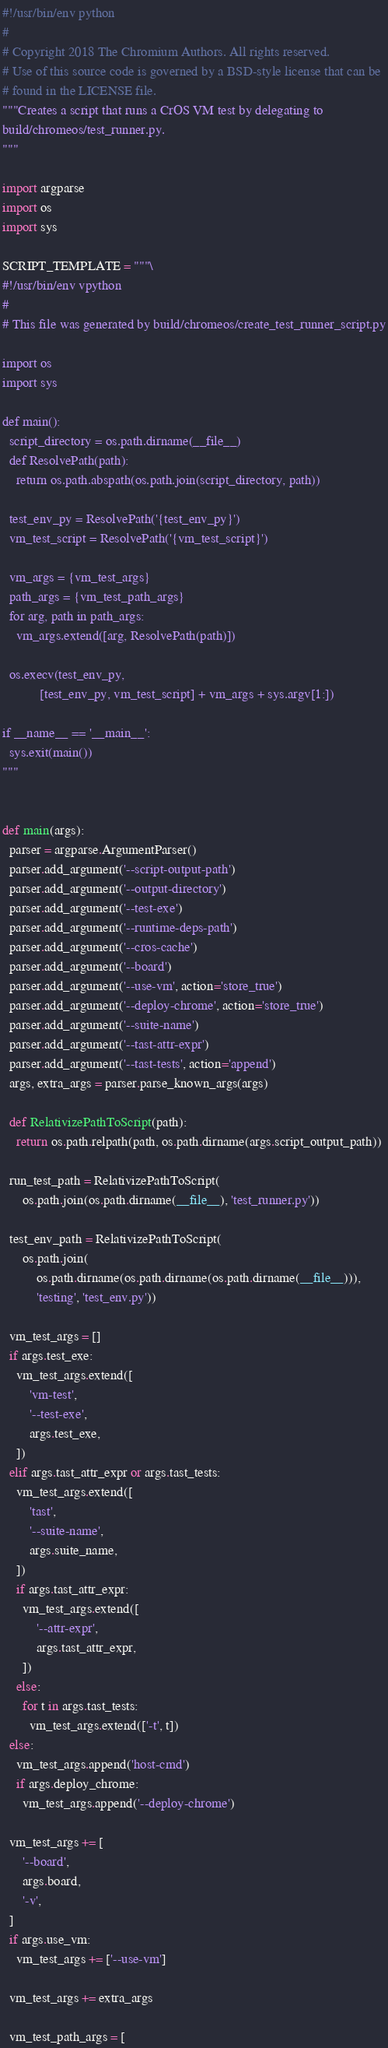<code> <loc_0><loc_0><loc_500><loc_500><_Python_>#!/usr/bin/env python
#
# Copyright 2018 The Chromium Authors. All rights reserved.
# Use of this source code is governed by a BSD-style license that can be
# found in the LICENSE file.
"""Creates a script that runs a CrOS VM test by delegating to
build/chromeos/test_runner.py.
"""

import argparse
import os
import sys

SCRIPT_TEMPLATE = """\
#!/usr/bin/env vpython
#
# This file was generated by build/chromeos/create_test_runner_script.py

import os
import sys

def main():
  script_directory = os.path.dirname(__file__)
  def ResolvePath(path):
    return os.path.abspath(os.path.join(script_directory, path))

  test_env_py = ResolvePath('{test_env_py}')
  vm_test_script = ResolvePath('{vm_test_script}')

  vm_args = {vm_test_args}
  path_args = {vm_test_path_args}
  for arg, path in path_args:
    vm_args.extend([arg, ResolvePath(path)])

  os.execv(test_env_py,
           [test_env_py, vm_test_script] + vm_args + sys.argv[1:])

if __name__ == '__main__':
  sys.exit(main())
"""


def main(args):
  parser = argparse.ArgumentParser()
  parser.add_argument('--script-output-path')
  parser.add_argument('--output-directory')
  parser.add_argument('--test-exe')
  parser.add_argument('--runtime-deps-path')
  parser.add_argument('--cros-cache')
  parser.add_argument('--board')
  parser.add_argument('--use-vm', action='store_true')
  parser.add_argument('--deploy-chrome', action='store_true')
  parser.add_argument('--suite-name')
  parser.add_argument('--tast-attr-expr')
  parser.add_argument('--tast-tests', action='append')
  args, extra_args = parser.parse_known_args(args)

  def RelativizePathToScript(path):
    return os.path.relpath(path, os.path.dirname(args.script_output_path))

  run_test_path = RelativizePathToScript(
      os.path.join(os.path.dirname(__file__), 'test_runner.py'))

  test_env_path = RelativizePathToScript(
      os.path.join(
          os.path.dirname(os.path.dirname(os.path.dirname(__file__))),
          'testing', 'test_env.py'))

  vm_test_args = []
  if args.test_exe:
    vm_test_args.extend([
        'vm-test',
        '--test-exe',
        args.test_exe,
    ])
  elif args.tast_attr_expr or args.tast_tests:
    vm_test_args.extend([
        'tast',
        '--suite-name',
        args.suite_name,
    ])
    if args.tast_attr_expr:
      vm_test_args.extend([
          '--attr-expr',
          args.tast_attr_expr,
      ])
    else:
      for t in args.tast_tests:
        vm_test_args.extend(['-t', t])
  else:
    vm_test_args.append('host-cmd')
    if args.deploy_chrome:
      vm_test_args.append('--deploy-chrome')

  vm_test_args += [
      '--board',
      args.board,
      '-v',
  ]
  if args.use_vm:
    vm_test_args += ['--use-vm']

  vm_test_args += extra_args

  vm_test_path_args = [</code> 